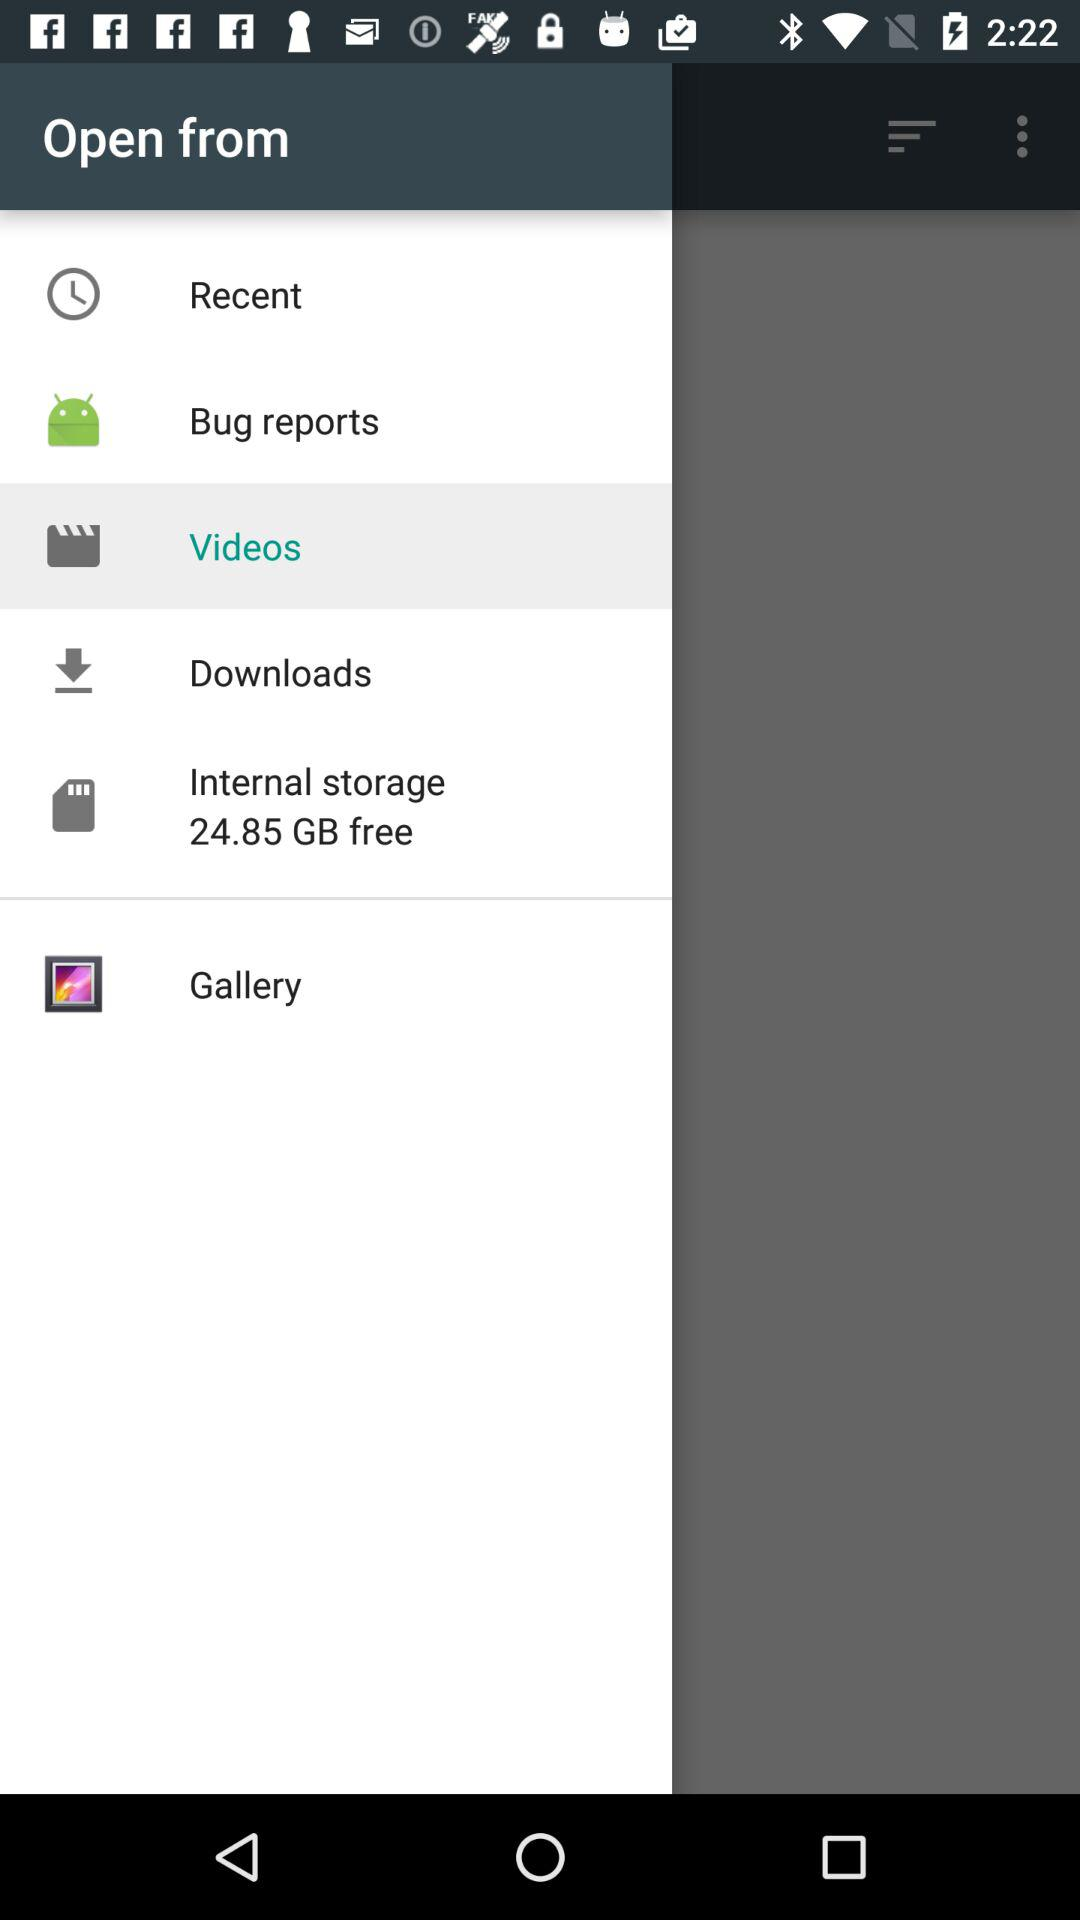How much is the free internal storage? The free internal storage is 24.85 GB. 